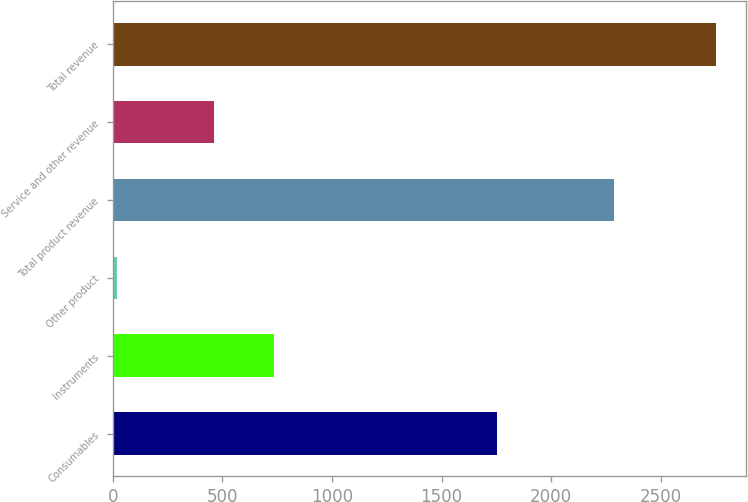<chart> <loc_0><loc_0><loc_500><loc_500><bar_chart><fcel>Consumables<fcel>Instruments<fcel>Other product<fcel>Total product revenue<fcel>Service and other revenue<fcel>Total revenue<nl><fcel>1753<fcel>736.1<fcel>21<fcel>2289<fcel>463<fcel>2752<nl></chart> 